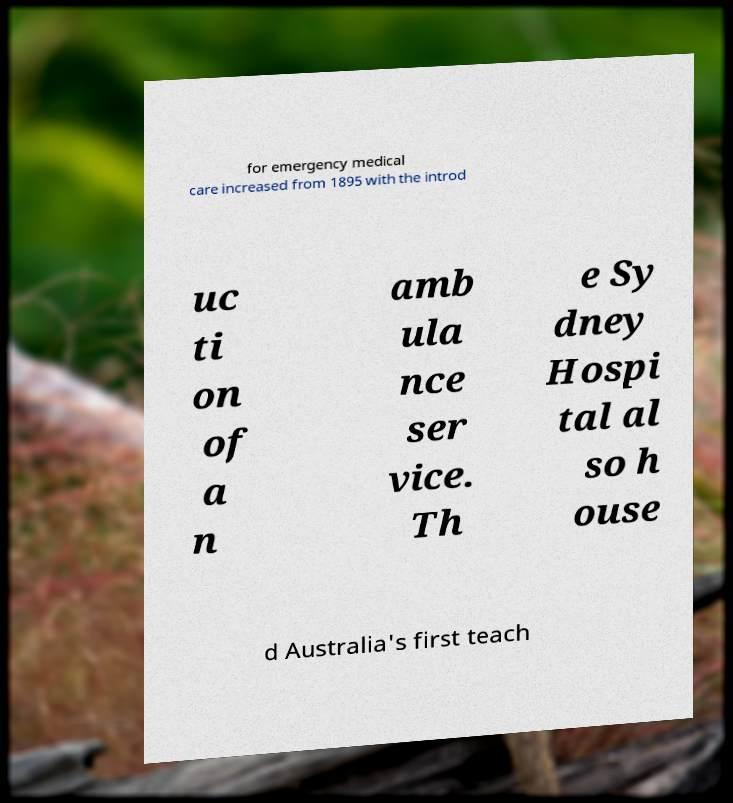Could you extract and type out the text from this image? for emergency medical care increased from 1895 with the introd uc ti on of a n amb ula nce ser vice. Th e Sy dney Hospi tal al so h ouse d Australia's first teach 